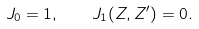<formula> <loc_0><loc_0><loc_500><loc_500>J _ { 0 } = 1 , \quad J _ { 1 } ( Z , Z ^ { \prime } ) = 0 .</formula> 